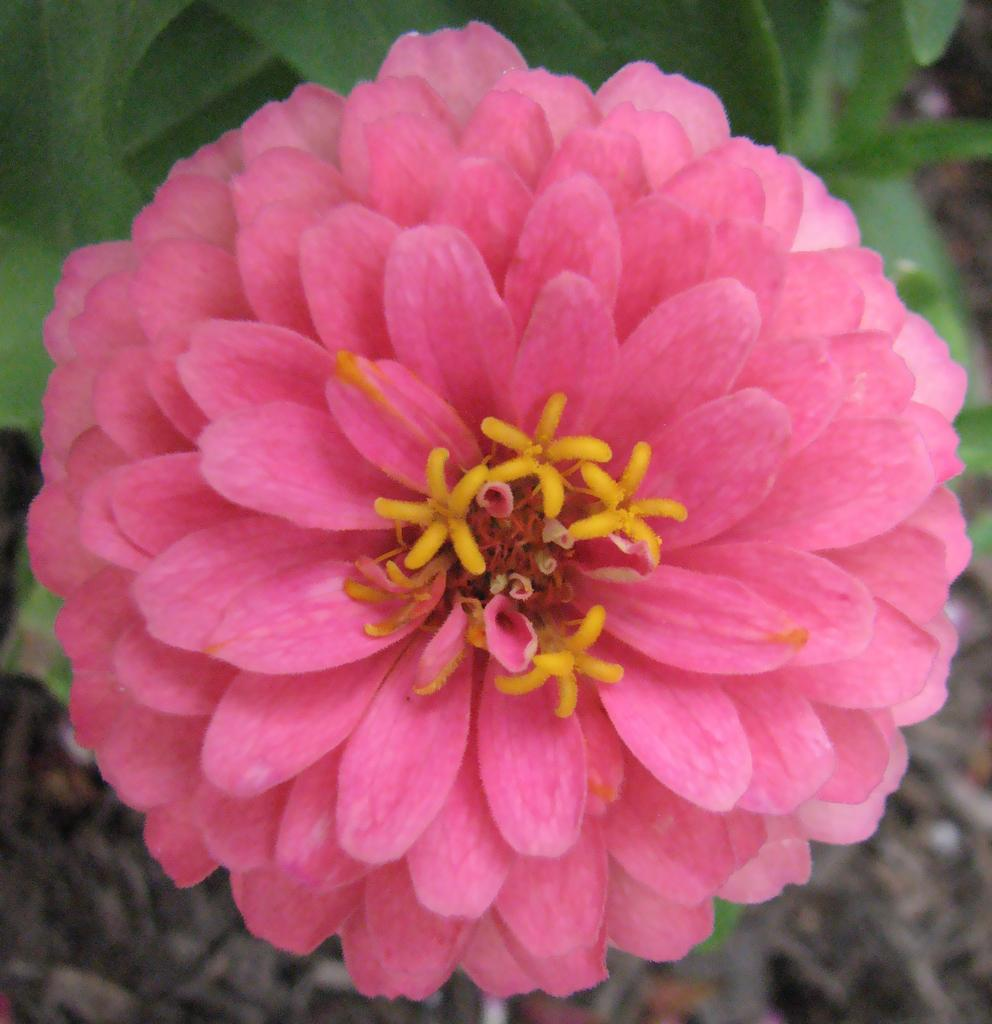What is the main subject of the image? There is a flower in the image. What can be seen in the background of the image? There are leaves visible in the background of the image. What type of guitar is being played in the image? There is no guitar present in the image; it features a flower and leaves. Where is the lunchroom located in the image? There is no lunchroom present in the image; it features a flower and leaves. 